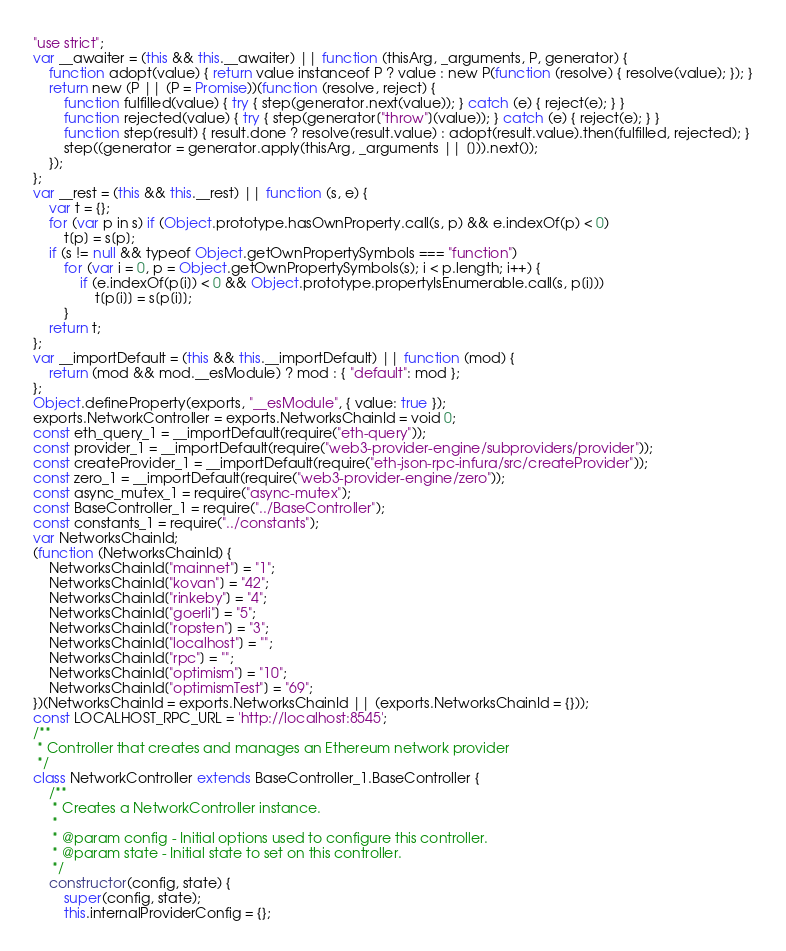Convert code to text. <code><loc_0><loc_0><loc_500><loc_500><_JavaScript_>"use strict";
var __awaiter = (this && this.__awaiter) || function (thisArg, _arguments, P, generator) {
    function adopt(value) { return value instanceof P ? value : new P(function (resolve) { resolve(value); }); }
    return new (P || (P = Promise))(function (resolve, reject) {
        function fulfilled(value) { try { step(generator.next(value)); } catch (e) { reject(e); } }
        function rejected(value) { try { step(generator["throw"](value)); } catch (e) { reject(e); } }
        function step(result) { result.done ? resolve(result.value) : adopt(result.value).then(fulfilled, rejected); }
        step((generator = generator.apply(thisArg, _arguments || [])).next());
    });
};
var __rest = (this && this.__rest) || function (s, e) {
    var t = {};
    for (var p in s) if (Object.prototype.hasOwnProperty.call(s, p) && e.indexOf(p) < 0)
        t[p] = s[p];
    if (s != null && typeof Object.getOwnPropertySymbols === "function")
        for (var i = 0, p = Object.getOwnPropertySymbols(s); i < p.length; i++) {
            if (e.indexOf(p[i]) < 0 && Object.prototype.propertyIsEnumerable.call(s, p[i]))
                t[p[i]] = s[p[i]];
        }
    return t;
};
var __importDefault = (this && this.__importDefault) || function (mod) {
    return (mod && mod.__esModule) ? mod : { "default": mod };
};
Object.defineProperty(exports, "__esModule", { value: true });
exports.NetworkController = exports.NetworksChainId = void 0;
const eth_query_1 = __importDefault(require("eth-query"));
const provider_1 = __importDefault(require("web3-provider-engine/subproviders/provider"));
const createProvider_1 = __importDefault(require("eth-json-rpc-infura/src/createProvider"));
const zero_1 = __importDefault(require("web3-provider-engine/zero"));
const async_mutex_1 = require("async-mutex");
const BaseController_1 = require("../BaseController");
const constants_1 = require("../constants");
var NetworksChainId;
(function (NetworksChainId) {
    NetworksChainId["mainnet"] = "1";
    NetworksChainId["kovan"] = "42";
    NetworksChainId["rinkeby"] = "4";
    NetworksChainId["goerli"] = "5";
    NetworksChainId["ropsten"] = "3";
    NetworksChainId["localhost"] = "";
    NetworksChainId["rpc"] = "";
    NetworksChainId["optimism"] = "10";
    NetworksChainId["optimismTest"] = "69";
})(NetworksChainId = exports.NetworksChainId || (exports.NetworksChainId = {}));
const LOCALHOST_RPC_URL = 'http://localhost:8545';
/**
 * Controller that creates and manages an Ethereum network provider
 */
class NetworkController extends BaseController_1.BaseController {
    /**
     * Creates a NetworkController instance.
     *
     * @param config - Initial options used to configure this controller.
     * @param state - Initial state to set on this controller.
     */
    constructor(config, state) {
        super(config, state);
        this.internalProviderConfig = {};</code> 